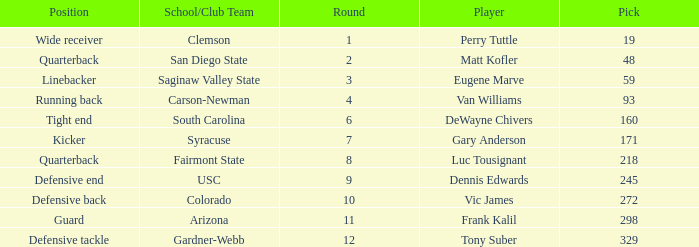Who plays linebacker? Eugene Marve. 